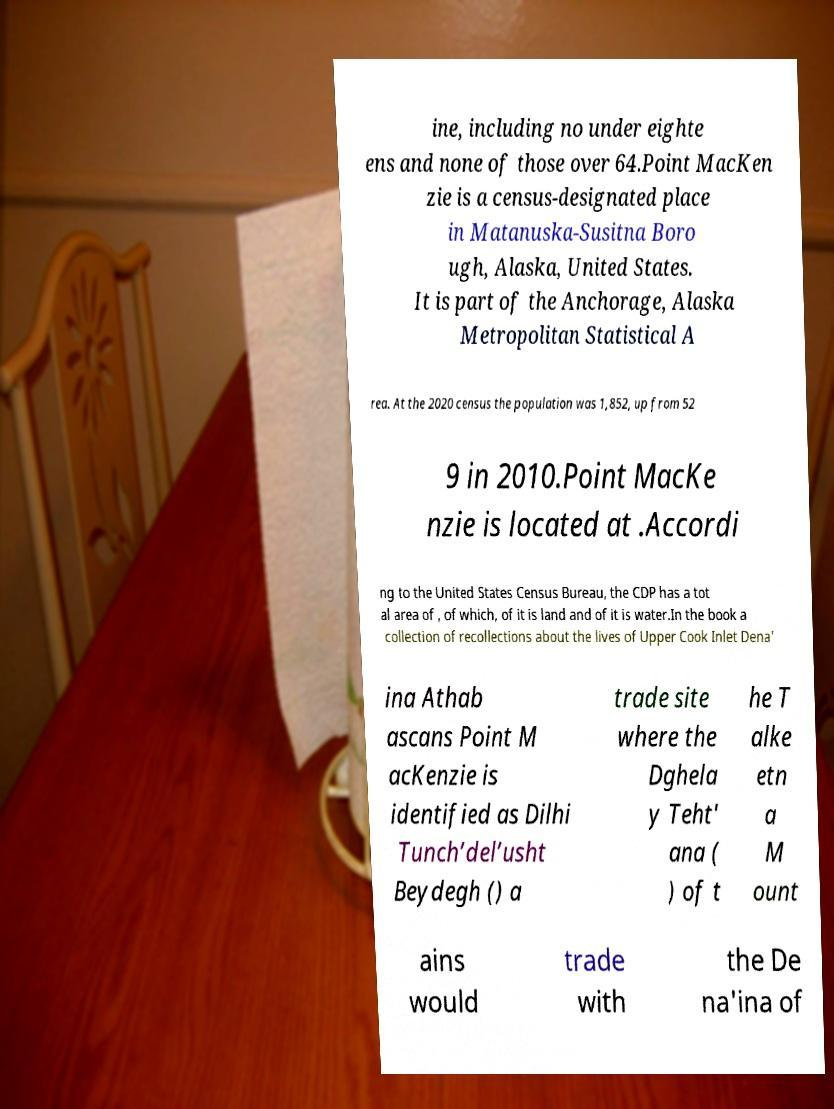Could you assist in decoding the text presented in this image and type it out clearly? ine, including no under eighte ens and none of those over 64.Point MacKen zie is a census-designated place in Matanuska-Susitna Boro ugh, Alaska, United States. It is part of the Anchorage, Alaska Metropolitan Statistical A rea. At the 2020 census the population was 1,852, up from 52 9 in 2010.Point MacKe nzie is located at .Accordi ng to the United States Census Bureau, the CDP has a tot al area of , of which, of it is land and of it is water.In the book a collection of recollections about the lives of Upper Cook Inlet Dena' ina Athab ascans Point M acKenzie is identified as Dilhi Tunch’del’usht Beydegh () a trade site where the Dghela y Teht' ana ( ) of t he T alke etn a M ount ains would trade with the De na'ina of 